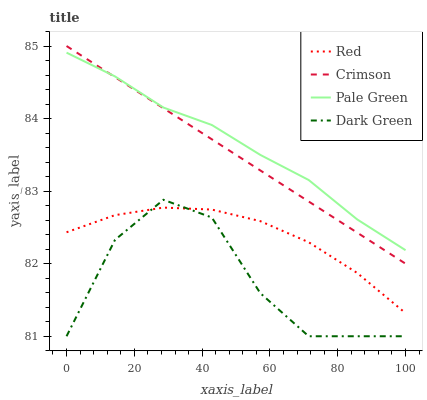Does Dark Green have the minimum area under the curve?
Answer yes or no. Yes. Does Pale Green have the maximum area under the curve?
Answer yes or no. Yes. Does Red have the minimum area under the curve?
Answer yes or no. No. Does Red have the maximum area under the curve?
Answer yes or no. No. Is Crimson the smoothest?
Answer yes or no. Yes. Is Dark Green the roughest?
Answer yes or no. Yes. Is Pale Green the smoothest?
Answer yes or no. No. Is Pale Green the roughest?
Answer yes or no. No. Does Dark Green have the lowest value?
Answer yes or no. Yes. Does Red have the lowest value?
Answer yes or no. No. Does Crimson have the highest value?
Answer yes or no. Yes. Does Pale Green have the highest value?
Answer yes or no. No. Is Dark Green less than Pale Green?
Answer yes or no. Yes. Is Pale Green greater than Dark Green?
Answer yes or no. Yes. Does Dark Green intersect Red?
Answer yes or no. Yes. Is Dark Green less than Red?
Answer yes or no. No. Is Dark Green greater than Red?
Answer yes or no. No. Does Dark Green intersect Pale Green?
Answer yes or no. No. 